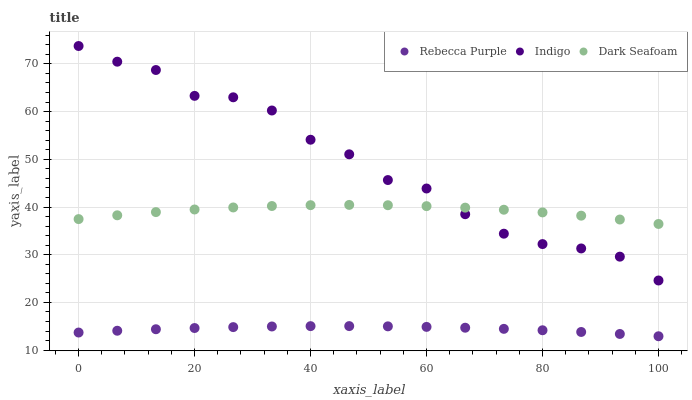Does Rebecca Purple have the minimum area under the curve?
Answer yes or no. Yes. Does Indigo have the maximum area under the curve?
Answer yes or no. Yes. Does Indigo have the minimum area under the curve?
Answer yes or no. No. Does Rebecca Purple have the maximum area under the curve?
Answer yes or no. No. Is Rebecca Purple the smoothest?
Answer yes or no. Yes. Is Indigo the roughest?
Answer yes or no. Yes. Is Indigo the smoothest?
Answer yes or no. No. Is Rebecca Purple the roughest?
Answer yes or no. No. Does Rebecca Purple have the lowest value?
Answer yes or no. Yes. Does Indigo have the lowest value?
Answer yes or no. No. Does Indigo have the highest value?
Answer yes or no. Yes. Does Rebecca Purple have the highest value?
Answer yes or no. No. Is Rebecca Purple less than Indigo?
Answer yes or no. Yes. Is Dark Seafoam greater than Rebecca Purple?
Answer yes or no. Yes. Does Indigo intersect Dark Seafoam?
Answer yes or no. Yes. Is Indigo less than Dark Seafoam?
Answer yes or no. No. Is Indigo greater than Dark Seafoam?
Answer yes or no. No. Does Rebecca Purple intersect Indigo?
Answer yes or no. No. 